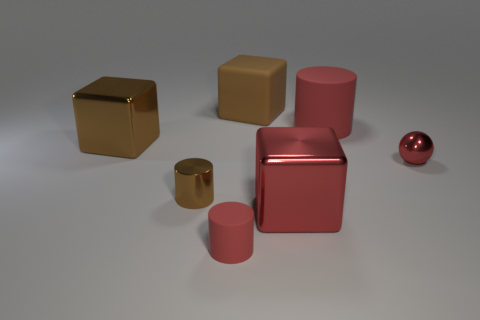Subtract all purple cubes. Subtract all gray cylinders. How many cubes are left? 3 Add 2 big gray balls. How many objects exist? 9 Subtract all cubes. How many objects are left? 4 Add 6 tiny brown metal objects. How many tiny brown metal objects exist? 7 Subtract 0 blue spheres. How many objects are left? 7 Subtract all rubber cylinders. Subtract all brown rubber things. How many objects are left? 4 Add 4 large brown rubber things. How many large brown rubber things are left? 5 